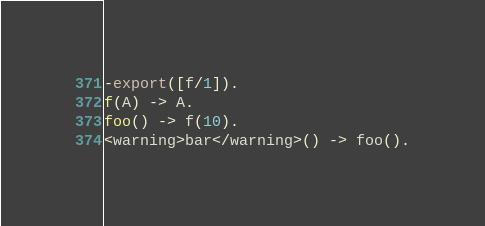<code> <loc_0><loc_0><loc_500><loc_500><_Erlang_>-export([f/1]).
f(A) -> A.
foo() -> f(10).
<warning>bar</warning>() -> foo().</code> 